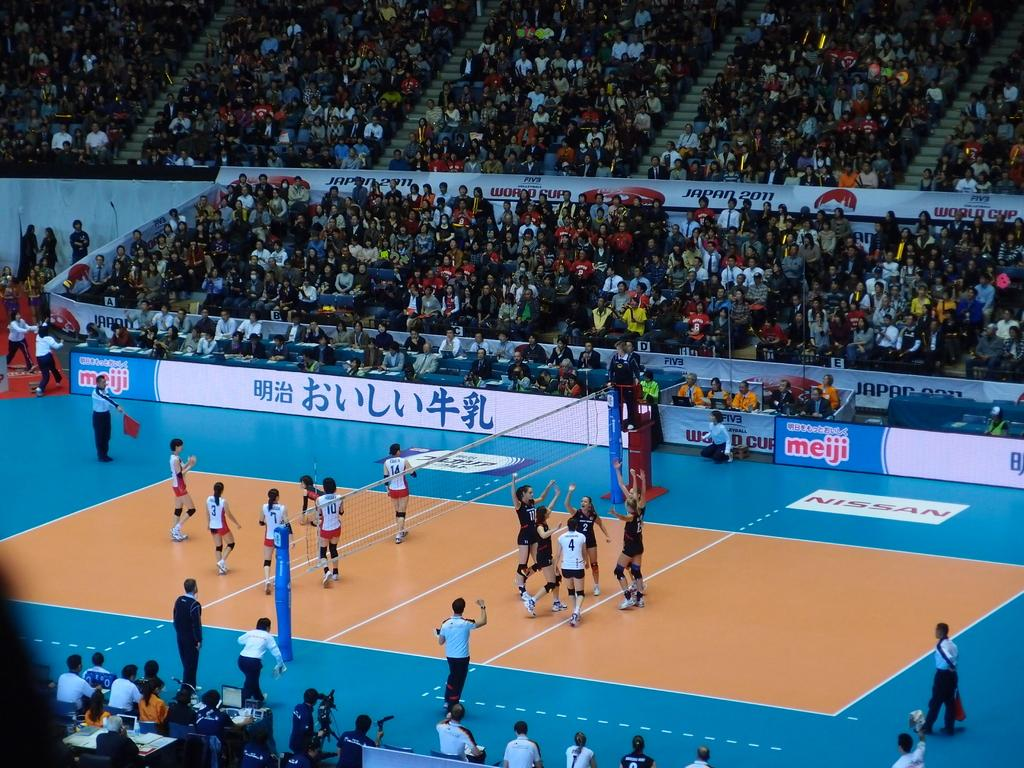<image>
Offer a succinct explanation of the picture presented. Volleyball players on the court with an ad that says NISSAN. 